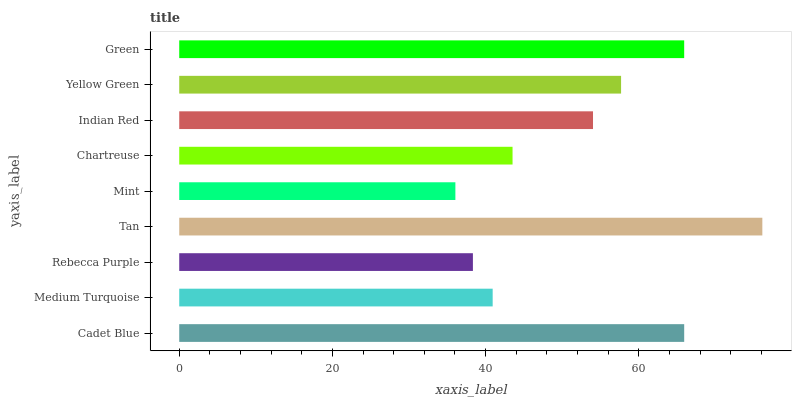Is Mint the minimum?
Answer yes or no. Yes. Is Tan the maximum?
Answer yes or no. Yes. Is Medium Turquoise the minimum?
Answer yes or no. No. Is Medium Turquoise the maximum?
Answer yes or no. No. Is Cadet Blue greater than Medium Turquoise?
Answer yes or no. Yes. Is Medium Turquoise less than Cadet Blue?
Answer yes or no. Yes. Is Medium Turquoise greater than Cadet Blue?
Answer yes or no. No. Is Cadet Blue less than Medium Turquoise?
Answer yes or no. No. Is Indian Red the high median?
Answer yes or no. Yes. Is Indian Red the low median?
Answer yes or no. Yes. Is Yellow Green the high median?
Answer yes or no. No. Is Rebecca Purple the low median?
Answer yes or no. No. 